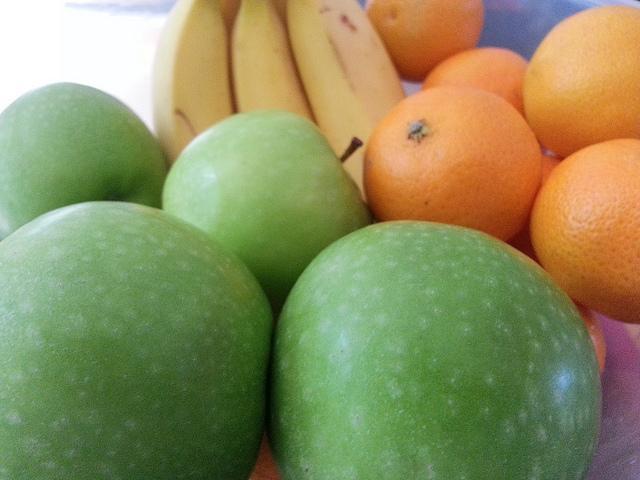How many apples are there?
Give a very brief answer. 4. How many oranges are in the photo?
Give a very brief answer. 5. How many apples can you see?
Give a very brief answer. 4. How many bananas can be seen?
Give a very brief answer. 2. How many people are wearing caps?
Give a very brief answer. 0. 